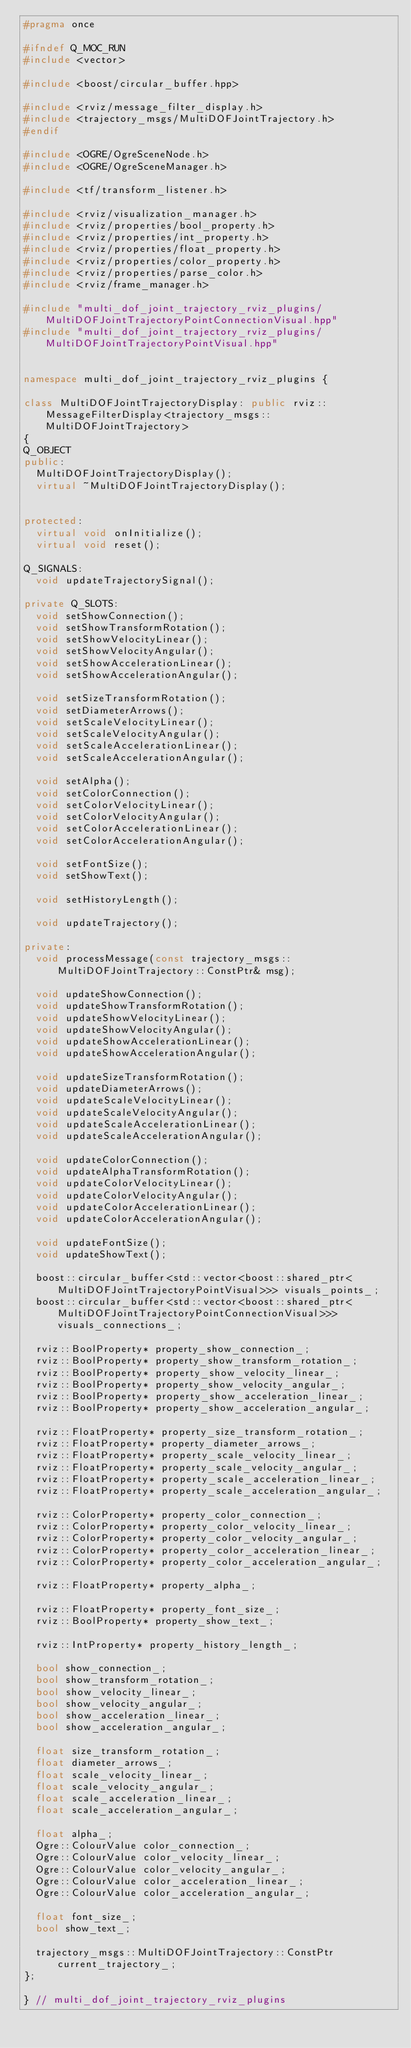<code> <loc_0><loc_0><loc_500><loc_500><_C++_>#pragma once

#ifndef Q_MOC_RUN
#include <vector>

#include <boost/circular_buffer.hpp>

#include <rviz/message_filter_display.h>
#include <trajectory_msgs/MultiDOFJointTrajectory.h>
#endif

#include <OGRE/OgreSceneNode.h>
#include <OGRE/OgreSceneManager.h>

#include <tf/transform_listener.h>

#include <rviz/visualization_manager.h>
#include <rviz/properties/bool_property.h>
#include <rviz/properties/int_property.h>
#include <rviz/properties/float_property.h>
#include <rviz/properties/color_property.h>
#include <rviz/properties/parse_color.h>
#include <rviz/frame_manager.h>

#include "multi_dof_joint_trajectory_rviz_plugins/MultiDOFJointTrajectoryPointConnectionVisual.hpp"
#include "multi_dof_joint_trajectory_rviz_plugins/MultiDOFJointTrajectoryPointVisual.hpp"


namespace multi_dof_joint_trajectory_rviz_plugins {

class MultiDOFJointTrajectoryDisplay: public rviz::MessageFilterDisplay<trajectory_msgs::MultiDOFJointTrajectory>
{
Q_OBJECT
public:
  MultiDOFJointTrajectoryDisplay();
  virtual ~MultiDOFJointTrajectoryDisplay();


protected:
  virtual void onInitialize();
  virtual void reset();

Q_SIGNALS:
  void updateTrajectorySignal();

private Q_SLOTS:
  void setShowConnection();
  void setShowTransformRotation();
  void setShowVelocityLinear();
  void setShowVelocityAngular();
  void setShowAccelerationLinear();
  void setShowAccelerationAngular();

  void setSizeTransformRotation();
  void setDiameterArrows();
  void setScaleVelocityLinear();
  void setScaleVelocityAngular();
  void setScaleAccelerationLinear();
  void setScaleAccelerationAngular();

  void setAlpha();
  void setColorConnection();
  void setColorVelocityLinear();
  void setColorVelocityAngular();
  void setColorAccelerationLinear();
  void setColorAccelerationAngular();

  void setFontSize();
  void setShowText();

  void setHistoryLength();

  void updateTrajectory();

private:
  void processMessage(const trajectory_msgs::MultiDOFJointTrajectory::ConstPtr& msg);

  void updateShowConnection();
  void updateShowTransformRotation();
  void updateShowVelocityLinear();
  void updateShowVelocityAngular();
  void updateShowAccelerationLinear();
  void updateShowAccelerationAngular();

  void updateSizeTransformRotation();
  void updateDiameterArrows();
  void updateScaleVelocityLinear();
  void updateScaleVelocityAngular();
  void updateScaleAccelerationLinear();
  void updateScaleAccelerationAngular();

  void updateColorConnection();
  void updateAlphaTransformRotation();
  void updateColorVelocityLinear();
  void updateColorVelocityAngular();
  void updateColorAccelerationLinear();
  void updateColorAccelerationAngular();

  void updateFontSize();
  void updateShowText();

  boost::circular_buffer<std::vector<boost::shared_ptr<MultiDOFJointTrajectoryPointVisual>>> visuals_points_;
  boost::circular_buffer<std::vector<boost::shared_ptr<MultiDOFJointTrajectoryPointConnectionVisual>>> visuals_connections_;

  rviz::BoolProperty* property_show_connection_;
  rviz::BoolProperty* property_show_transform_rotation_;
  rviz::BoolProperty* property_show_velocity_linear_;
  rviz::BoolProperty* property_show_velocity_angular_;
  rviz::BoolProperty* property_show_acceleration_linear_;
  rviz::BoolProperty* property_show_acceleration_angular_;

  rviz::FloatProperty* property_size_transform_rotation_;
  rviz::FloatProperty* property_diameter_arrows_;
  rviz::FloatProperty* property_scale_velocity_linear_;
  rviz::FloatProperty* property_scale_velocity_angular_;
  rviz::FloatProperty* property_scale_acceleration_linear_;
  rviz::FloatProperty* property_scale_acceleration_angular_;

  rviz::ColorProperty* property_color_connection_;
  rviz::ColorProperty* property_color_velocity_linear_;
  rviz::ColorProperty* property_color_velocity_angular_;
  rviz::ColorProperty* property_color_acceleration_linear_;
  rviz::ColorProperty* property_color_acceleration_angular_;

  rviz::FloatProperty* property_alpha_;

  rviz::FloatProperty* property_font_size_;
  rviz::BoolProperty* property_show_text_;

  rviz::IntProperty* property_history_length_;

  bool show_connection_;
  bool show_transform_rotation_;
  bool show_velocity_linear_;
  bool show_velocity_angular_;
  bool show_acceleration_linear_;
  bool show_acceleration_angular_;

  float size_transform_rotation_;
  float diameter_arrows_;
  float scale_velocity_linear_;
  float scale_velocity_angular_;
  float scale_acceleration_linear_;
  float scale_acceleration_angular_;

  float alpha_;
  Ogre::ColourValue color_connection_;
  Ogre::ColourValue color_velocity_linear_;
  Ogre::ColourValue color_velocity_angular_;
  Ogre::ColourValue color_acceleration_linear_;
  Ogre::ColourValue color_acceleration_angular_;

  float font_size_;
  bool show_text_;

  trajectory_msgs::MultiDOFJointTrajectory::ConstPtr current_trajectory_;
};

} // multi_dof_joint_trajectory_rviz_plugins
</code> 